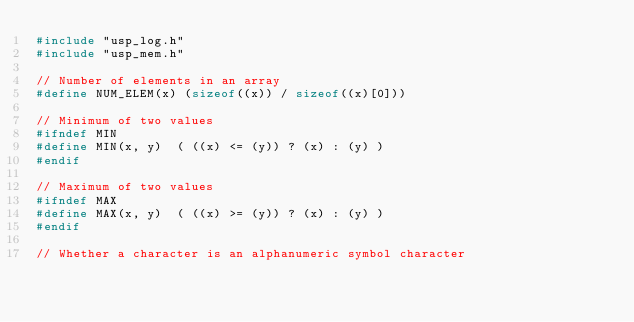<code> <loc_0><loc_0><loc_500><loc_500><_C_>#include "usp_log.h"
#include "usp_mem.h"

// Number of elements in an array
#define NUM_ELEM(x) (sizeof((x)) / sizeof((x)[0]))

// Minimum of two values
#ifndef MIN
#define MIN(x, y)  ( ((x) <= (y)) ? (x) : (y) )
#endif

// Maximum of two values
#ifndef MAX
#define MAX(x, y)  ( ((x) >= (y)) ? (x) : (y) )
#endif

// Whether a character is an alphanumeric symbol character</code> 